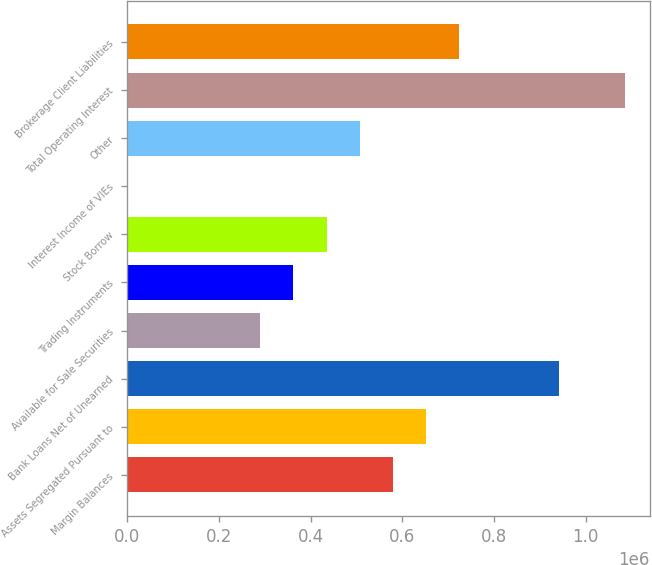Convert chart to OTSL. <chart><loc_0><loc_0><loc_500><loc_500><bar_chart><fcel>Margin Balances<fcel>Assets Segregated Pursuant to<fcel>Bank Loans Net of Unearned<fcel>Available for Sale Securities<fcel>Trading Instruments<fcel>Stock Borrow<fcel>Interest Income of VIEs<fcel>Other<fcel>Total Operating Interest<fcel>Brokerage Client Liabilities<nl><fcel>579382<fcel>651722<fcel>941085<fcel>290019<fcel>362360<fcel>434701<fcel>657<fcel>507041<fcel>1.08577e+06<fcel>724063<nl></chart> 